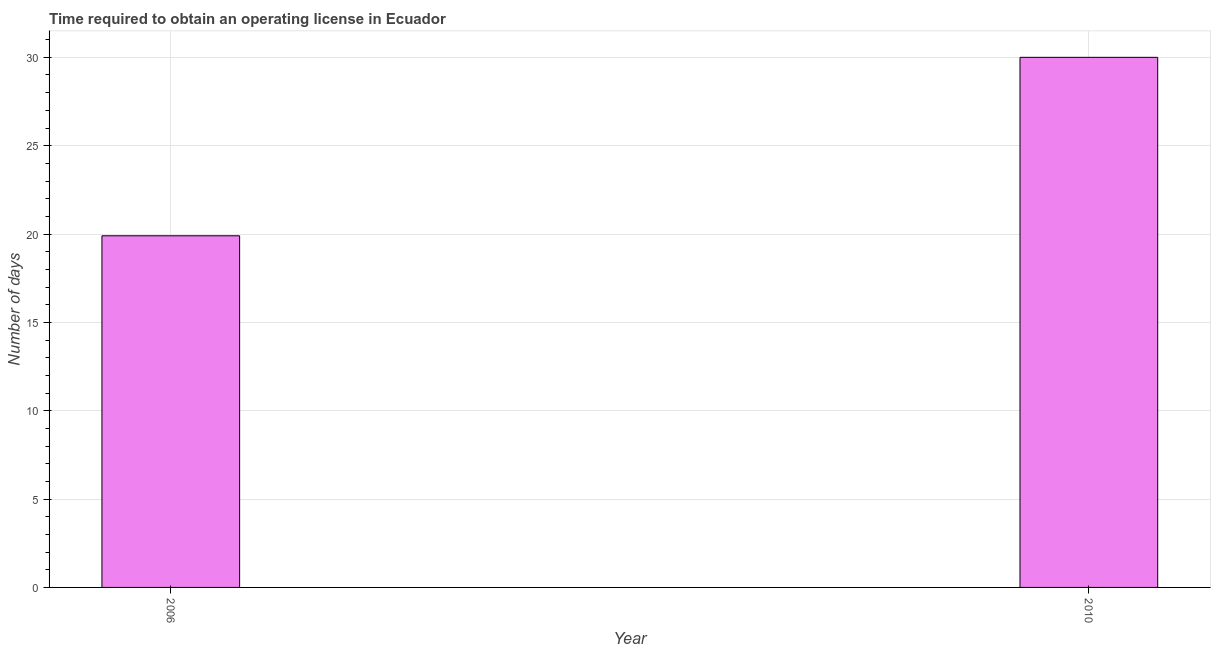Does the graph contain any zero values?
Provide a succinct answer. No. What is the title of the graph?
Offer a very short reply. Time required to obtain an operating license in Ecuador. What is the label or title of the Y-axis?
Ensure brevity in your answer.  Number of days. What is the number of days to obtain operating license in 2006?
Offer a terse response. 19.9. Across all years, what is the maximum number of days to obtain operating license?
Give a very brief answer. 30. Across all years, what is the minimum number of days to obtain operating license?
Ensure brevity in your answer.  19.9. In which year was the number of days to obtain operating license minimum?
Ensure brevity in your answer.  2006. What is the sum of the number of days to obtain operating license?
Give a very brief answer. 49.9. What is the average number of days to obtain operating license per year?
Provide a short and direct response. 24.95. What is the median number of days to obtain operating license?
Your answer should be compact. 24.95. Do a majority of the years between 2006 and 2010 (inclusive) have number of days to obtain operating license greater than 16 days?
Ensure brevity in your answer.  Yes. What is the ratio of the number of days to obtain operating license in 2006 to that in 2010?
Provide a succinct answer. 0.66. Is the number of days to obtain operating license in 2006 less than that in 2010?
Your response must be concise. Yes. Are all the bars in the graph horizontal?
Offer a terse response. No. Are the values on the major ticks of Y-axis written in scientific E-notation?
Make the answer very short. No. What is the Number of days in 2006?
Provide a short and direct response. 19.9. What is the Number of days in 2010?
Provide a short and direct response. 30. What is the ratio of the Number of days in 2006 to that in 2010?
Your response must be concise. 0.66. 